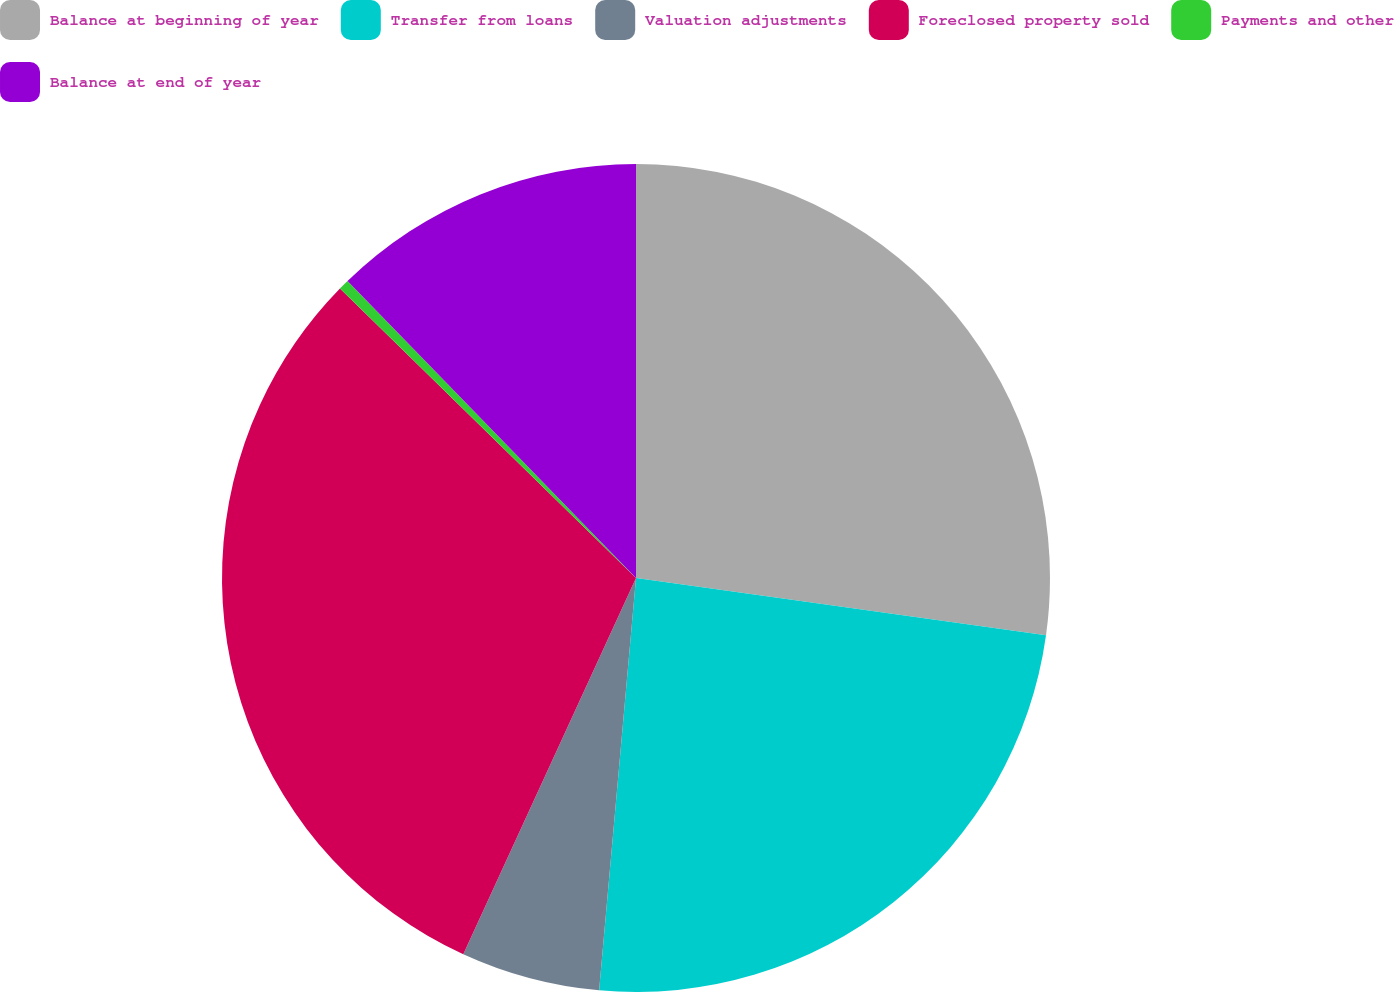Convert chart. <chart><loc_0><loc_0><loc_500><loc_500><pie_chart><fcel>Balance at beginning of year<fcel>Transfer from loans<fcel>Valuation adjustments<fcel>Foreclosed property sold<fcel>Payments and other<fcel>Balance at end of year<nl><fcel>27.21%<fcel>24.21%<fcel>5.43%<fcel>30.47%<fcel>0.41%<fcel>12.27%<nl></chart> 